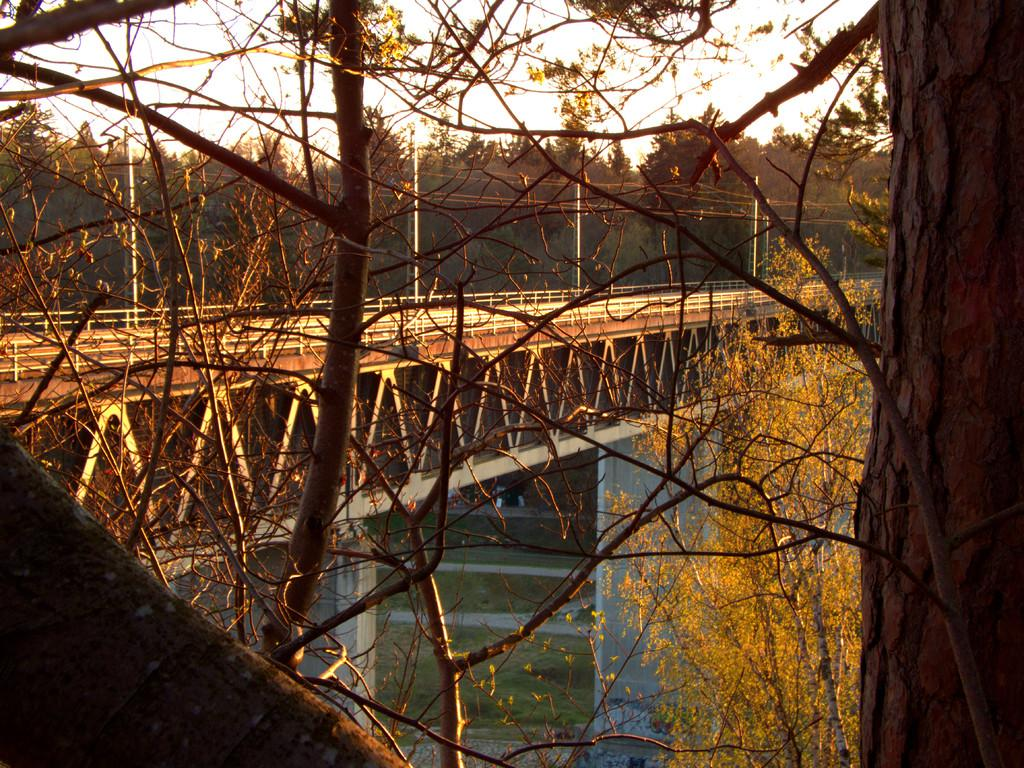What type of structure can be seen in the image? There is a bridge in the image. What else is present in the image besides the bridge? There are poles, trees, and water visible in the image. What is the condition of the sky in the image? The sky is cloudy in the image. What type of church can be seen in the image? There is no church present in the image; it features a bridge, poles, trees, and water. What is the reaction of the people in the image when they see the surprise? There are no people or surprises depicted in the image. 